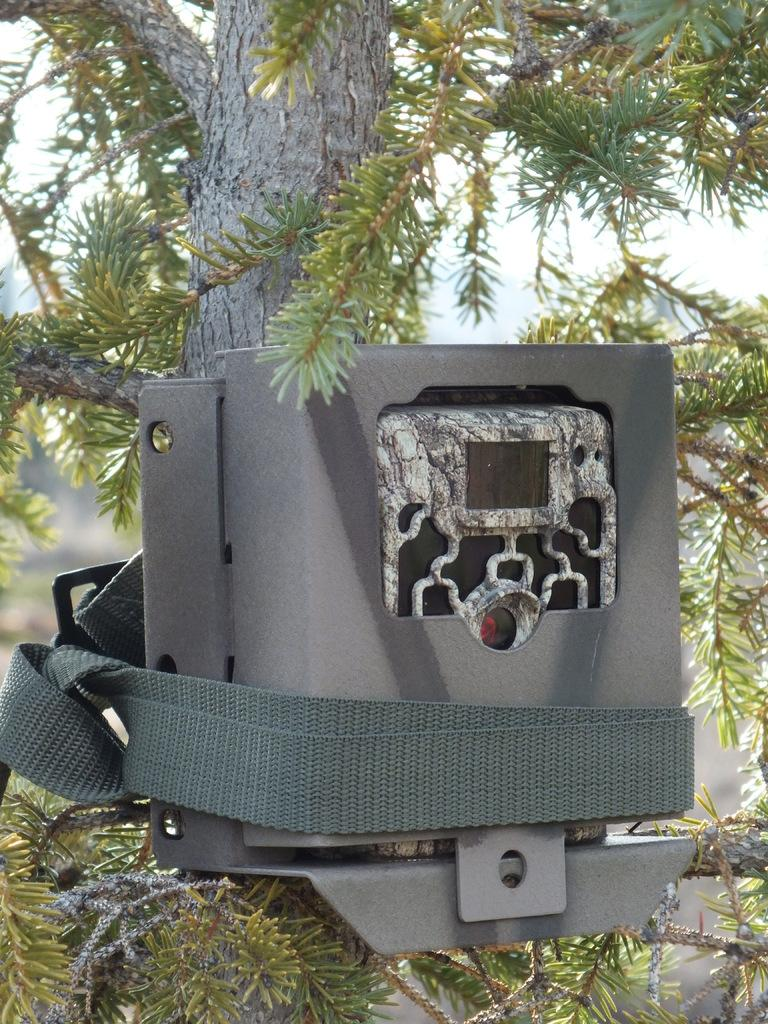What is the primary feature of the image? The primary feature of the image is the presence of many trees. Can you describe any additional objects or features related to the trees? Yes, there is an object on one of the trees. Is the ground made of quicksand in the image? There is no indication of quicksand in the image; it features trees and an object on one of the trees. Can you see a porter carrying luggage in the image? There is no porter carrying luggage present in the image. 